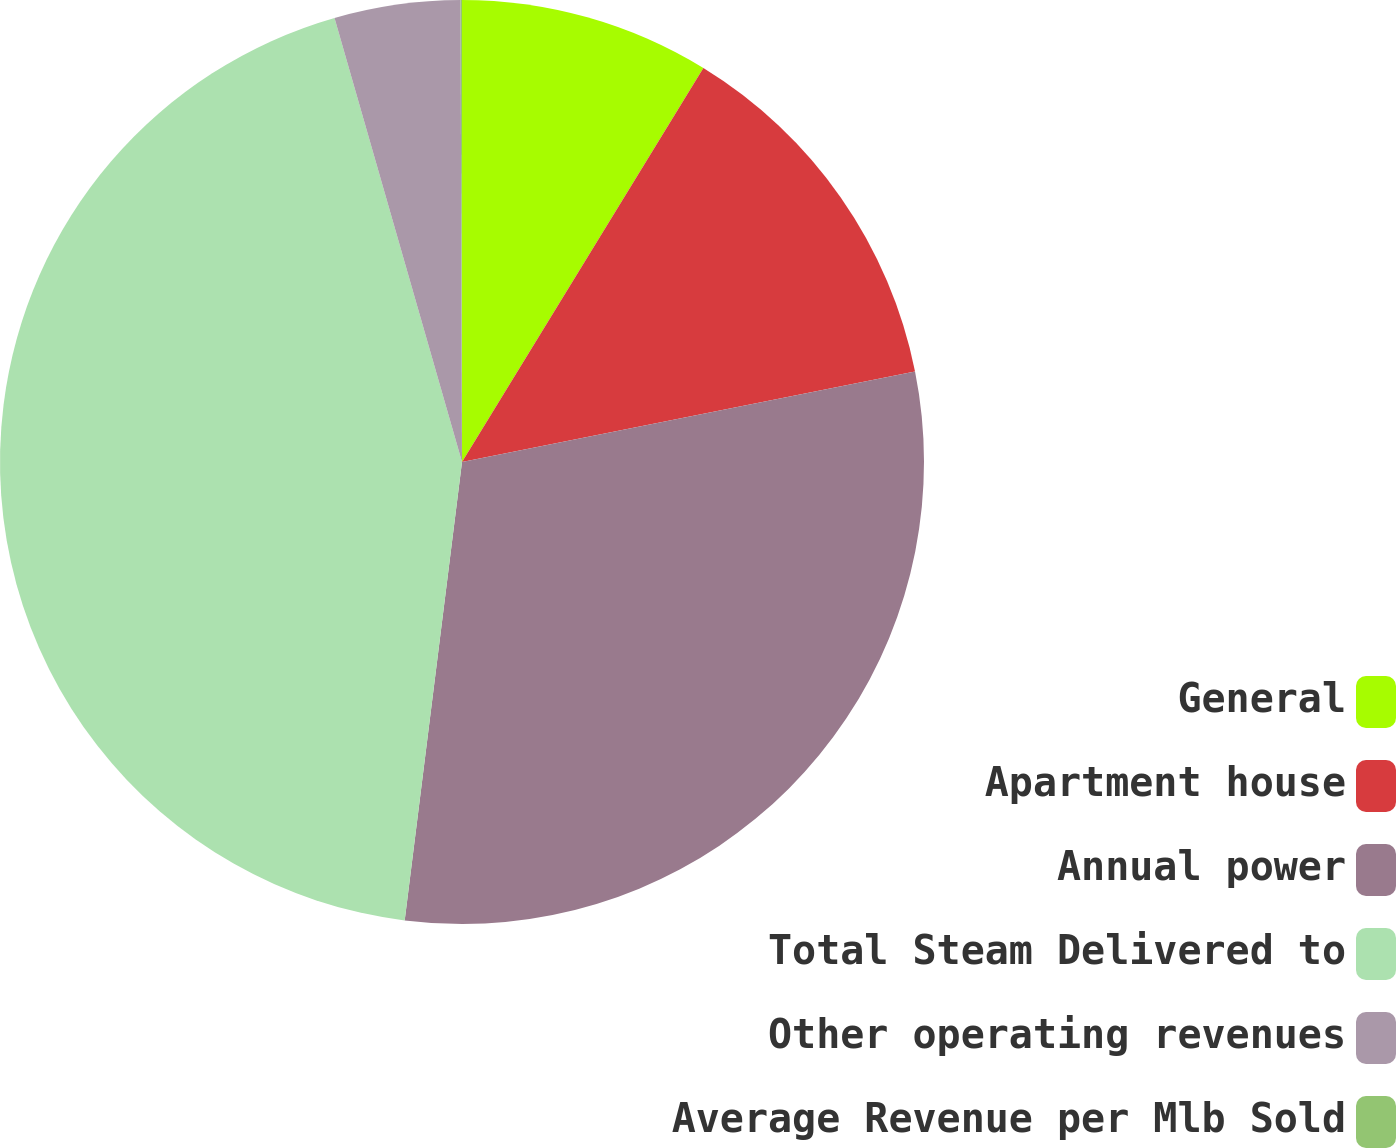<chart> <loc_0><loc_0><loc_500><loc_500><pie_chart><fcel>General<fcel>Apartment house<fcel>Annual power<fcel>Total Steam Delivered to<fcel>Other operating revenues<fcel>Average Revenue per Mlb Sold<nl><fcel>8.75%<fcel>13.11%<fcel>30.12%<fcel>43.57%<fcel>4.4%<fcel>0.05%<nl></chart> 